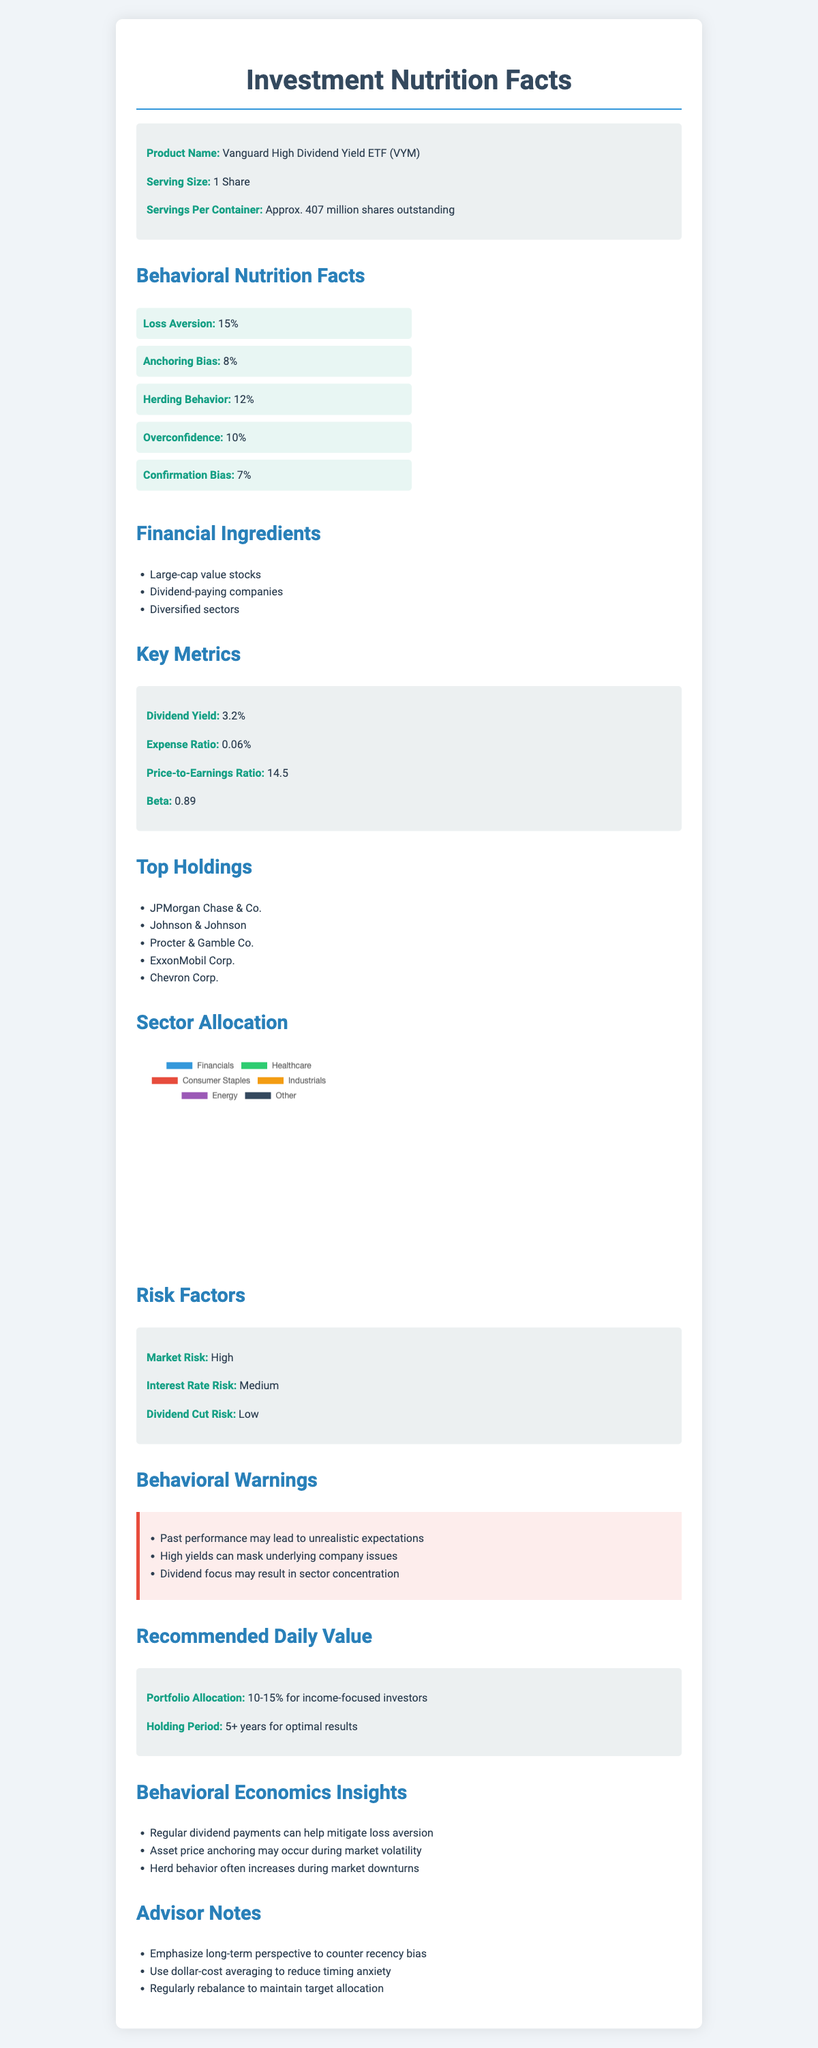what is the serving size of the product? The document specifies that the serving size is "1 Share."
Answer: 1 Share what is the dividend yield of this ETF? The key metrics section mentions that the dividend yield is 3.2%.
Answer: 3.2% who is included in the top holdings? The top holdings section lists these companies.
Answer: JPMorgan Chase & Co., Johnson & Johnson, Procter & Gamble Co., ExxonMobil Corp., Chevron Corp. what is the risk level of market risk? The risk factors section labels market risk as high.
Answer: High what is the recommended portfolio allocation for income-focused investors? The recommended daily value section advises a 10-15% portfolio allocation for income-focused investors.
Answer: 10-15% how much of the ETF's allocation is in the healthcare sector? A. 10% B. 15% C. 20% D. 25% The sector allocation section shows that healthcare is 15%.
Answer: B which of the following is an example of a behavioral bias mentioned in the document? I. Anchoring Bias II. Recency Bias III. Overconfidence The document mentions anchoring bias and overconfidence as behavioral biases, but not recency bias.
Answer: I and III is the beta of the ETF above 1.0? The key metrics section states that the beta is 0.89, which is below 1.0.
Answer: No can you determine the exact number of shares held by Johnson & Johnson in the ETF? The document does not provide the specific number of shares of Johnson & Johnson held.
Answer: Cannot be determined summarize the main idea of this document. The document presents an investment profile of Vanguard High Dividend Yield ETF (VYM), outlining key financial metrics, risk factors, sector allocations, behavioral biases, and advisories for potential investors, emphasizing the application of behavioral economics principles.
Answer: Investment Nutrition Facts for Vanguard High Dividend Yield ETF (VYM) emphasizing behavioral biases affecting investors. 